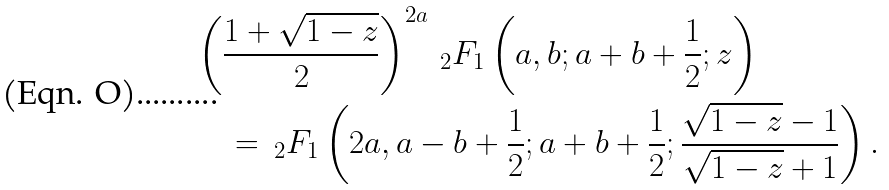Convert formula to latex. <formula><loc_0><loc_0><loc_500><loc_500>& \left ( \frac { 1 + \sqrt { 1 - z } } 2 \right ) ^ { 2 a } \, _ { 2 } F _ { 1 } \left ( a , b ; a + b + \frac { 1 } { 2 } ; z \right ) \\ & \quad = \, _ { 2 } F _ { 1 } \left ( 2 a , a - b + \frac { 1 } { 2 } ; a + b + \frac { 1 } { 2 } ; \frac { \sqrt { 1 - z } - 1 } { \sqrt { 1 - z } + 1 } \right ) .</formula> 